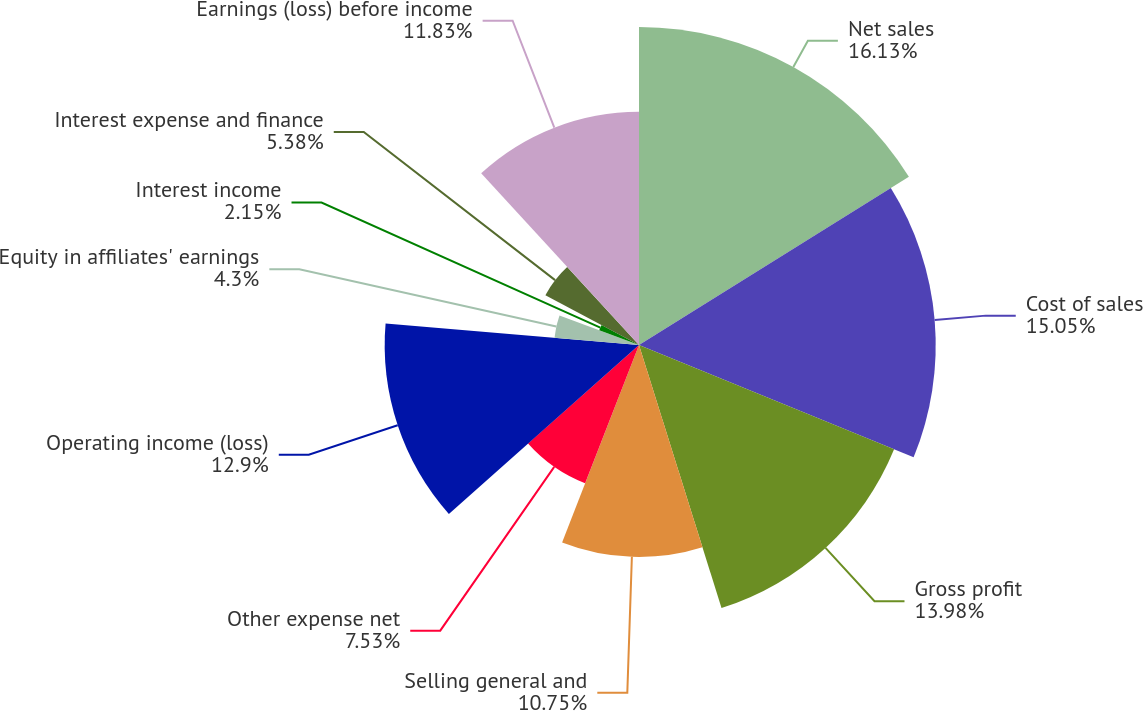Convert chart. <chart><loc_0><loc_0><loc_500><loc_500><pie_chart><fcel>Net sales<fcel>Cost of sales<fcel>Gross profit<fcel>Selling general and<fcel>Other expense net<fcel>Operating income (loss)<fcel>Equity in affiliates' earnings<fcel>Interest income<fcel>Interest expense and finance<fcel>Earnings (loss) before income<nl><fcel>16.13%<fcel>15.05%<fcel>13.98%<fcel>10.75%<fcel>7.53%<fcel>12.9%<fcel>4.3%<fcel>2.15%<fcel>5.38%<fcel>11.83%<nl></chart> 